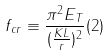<formula> <loc_0><loc_0><loc_500><loc_500>f _ { c r } \equiv \frac { \pi ^ { 2 } E _ { T } } { ( \frac { K L } { r } ) ^ { 2 } } ( 2 )</formula> 